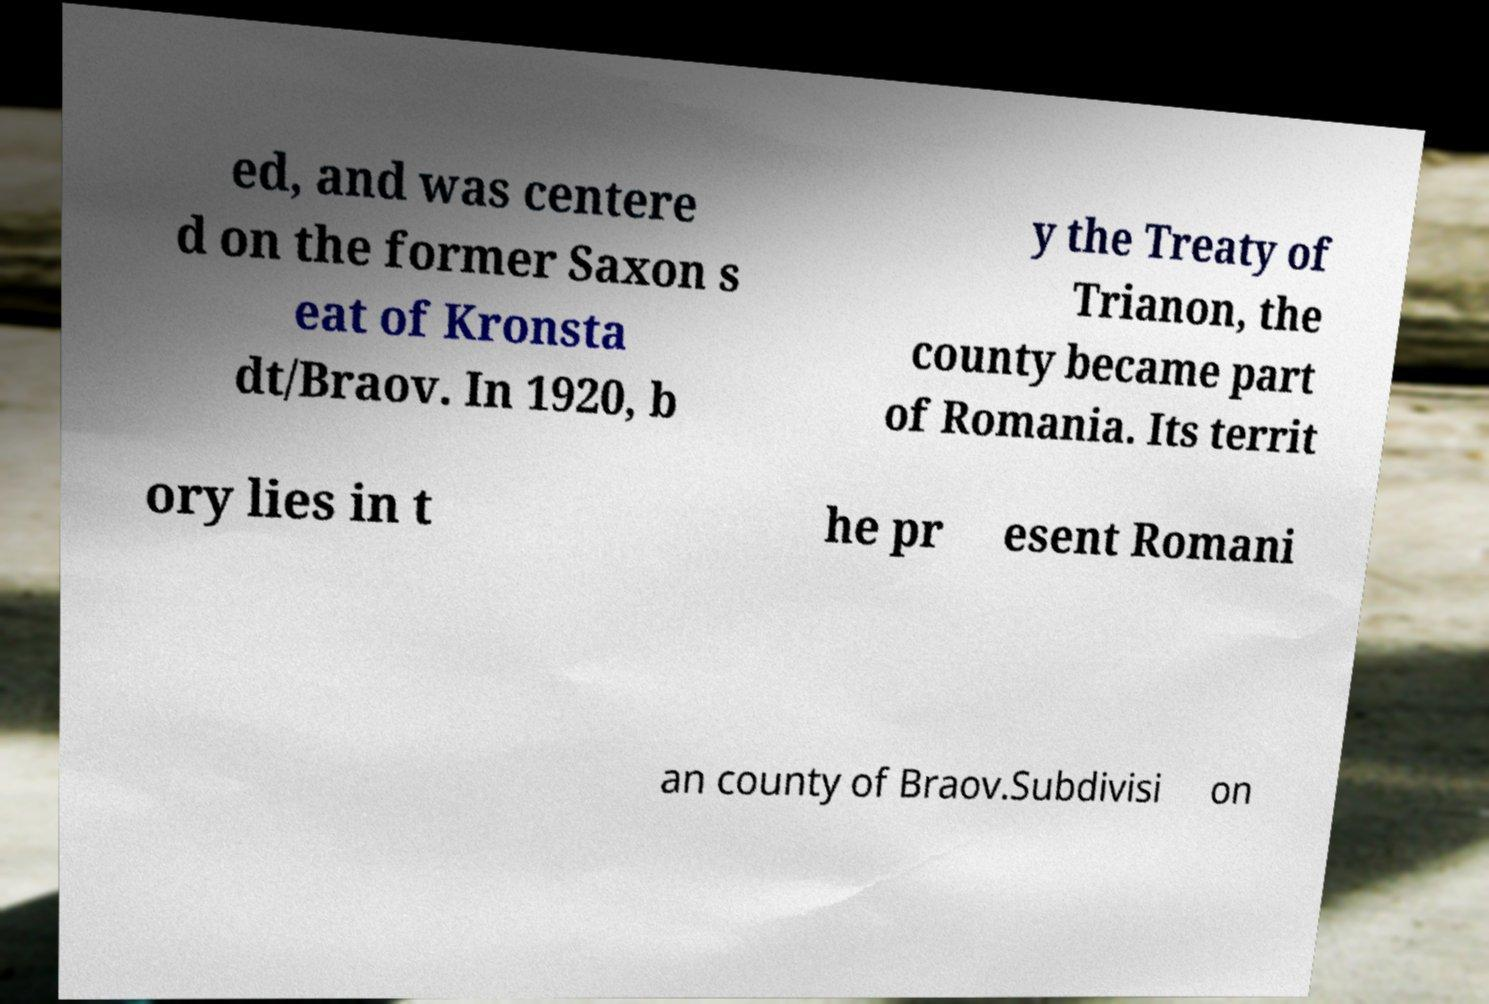Could you extract and type out the text from this image? ed, and was centere d on the former Saxon s eat of Kronsta dt/Braov. In 1920, b y the Treaty of Trianon, the county became part of Romania. Its territ ory lies in t he pr esent Romani an county of Braov.Subdivisi on 